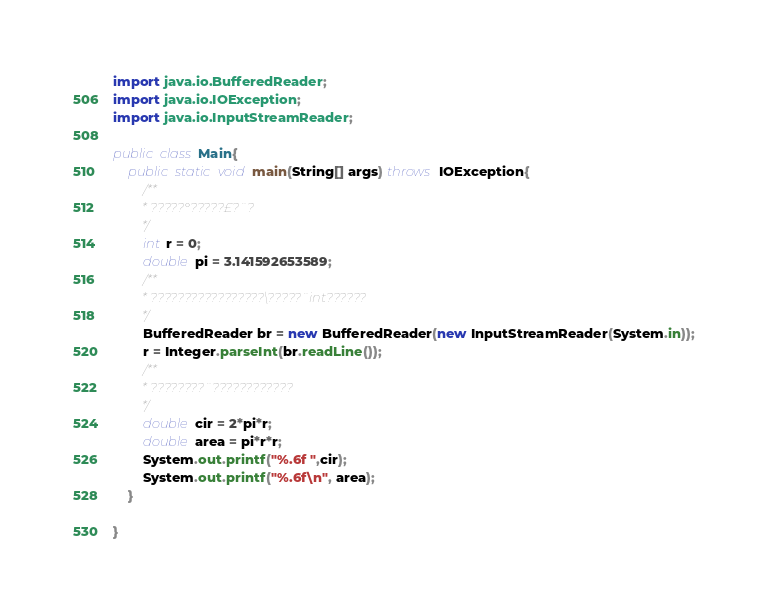<code> <loc_0><loc_0><loc_500><loc_500><_Java_>import java.io.BufferedReader;
import java.io.IOException;
import java.io.InputStreamReader;

public class Main{
	public static void main(String[] args) throws IOException{
		/**
		 * ?????°?????£?¨?
		 */
		int r = 0;
		double pi = 3.141592653589;
		/**
		 * ?????????????????\?????¨int??????
		 */
		BufferedReader br = new BufferedReader(new InputStreamReader(System.in));
		r = Integer.parseInt(br.readLine());
		/**
		 * ????????¨????????????
		 */
		double cir = 2*pi*r;
		double area = pi*r*r;
		System.out.printf("%.6f ",cir);
		System.out.printf("%.6f\n", area);
	}

}</code> 